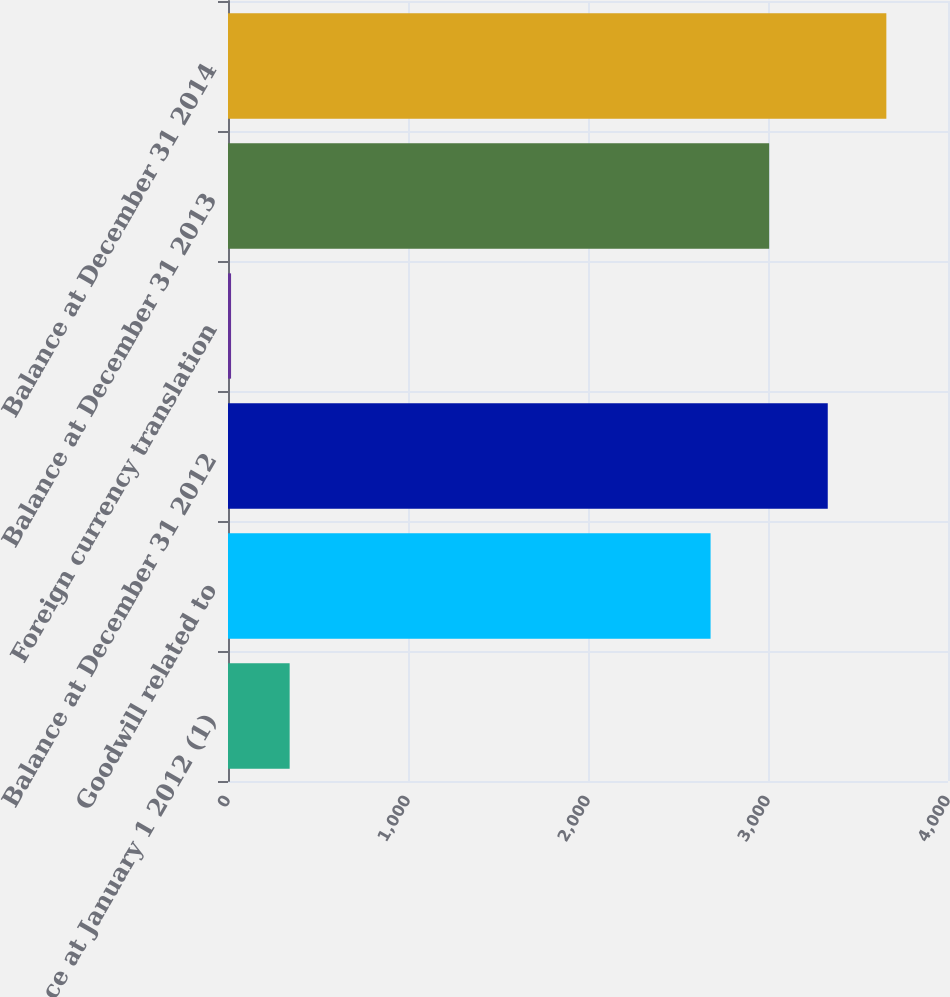<chart> <loc_0><loc_0><loc_500><loc_500><bar_chart><fcel>Balance at January 1 2012 (1)<fcel>Goodwill related to<fcel>Balance at December 31 2012<fcel>Foreign currency translation<fcel>Balance at December 31 2013<fcel>Balance at December 31 2014<nl><fcel>342.5<fcel>2681<fcel>3332<fcel>17<fcel>3006.5<fcel>3657.5<nl></chart> 